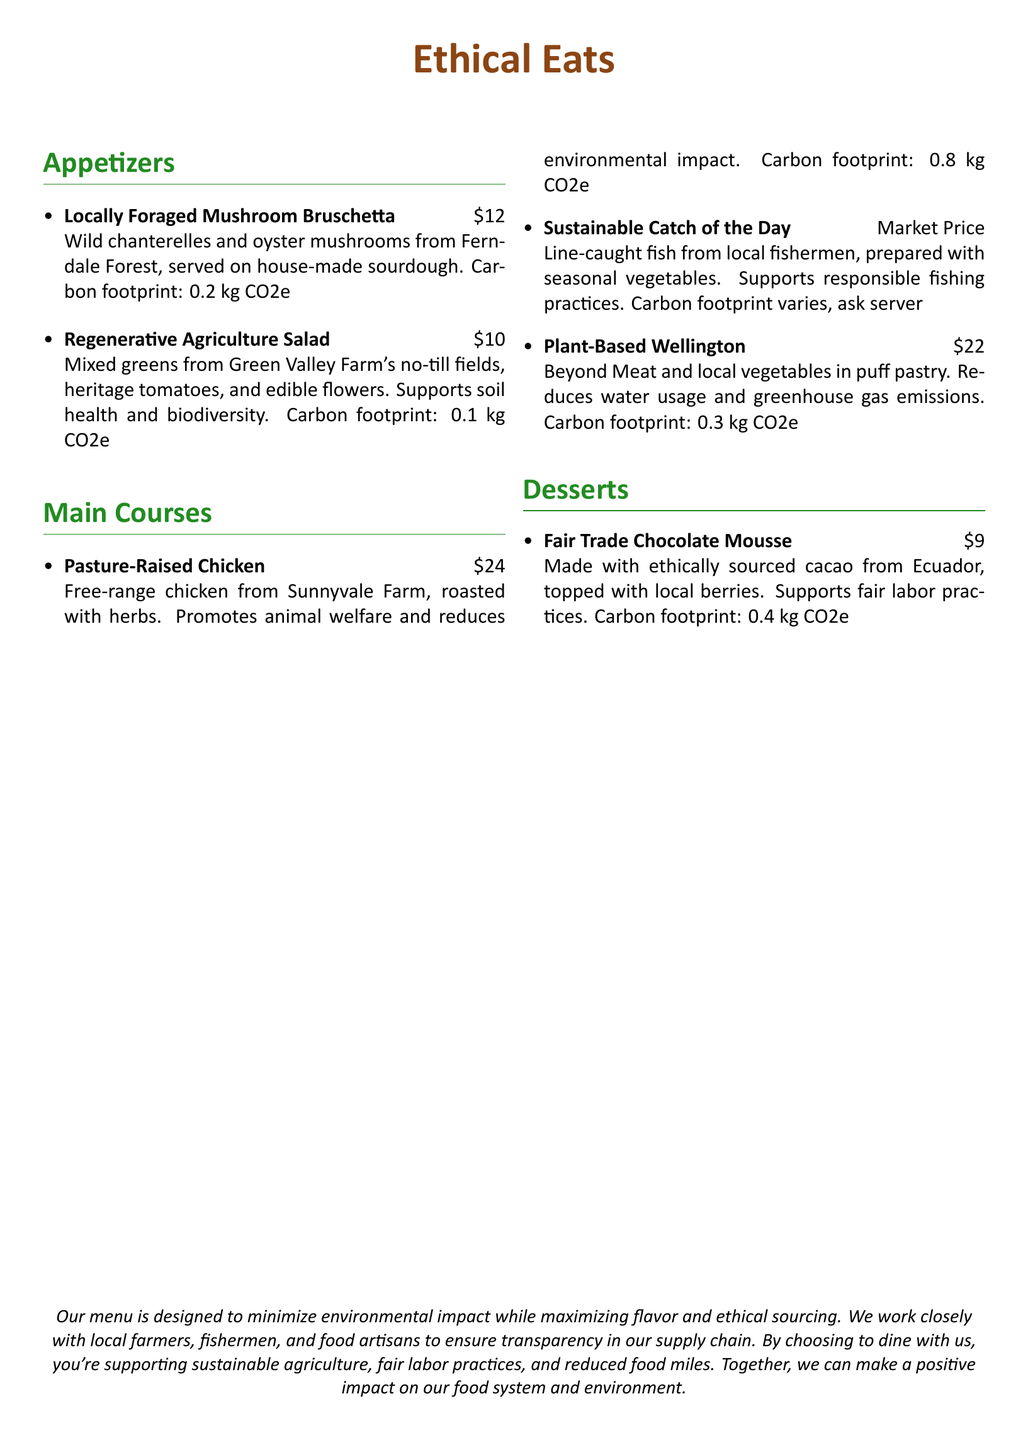What is the price of the Locally Foraged Mushroom Bruschetta? The price is listed next to the dish name in the menu.
Answer: $12 What ingredient is used in the Fair Trade Chocolate Mousse? The main ingredient is indicated in the description of the dessert.
Answer: Cacao What farming practice is mentioned in relation to the Regenerative Agriculture Salad? The description of the salad specifies the farming practice used for the greens.
Answer: No-till What is the carbon footprint of the Pasture-Raised Chicken? The carbon footprint is provided in the dish description for the chicken.
Answer: 0.8 kg CO2e Which dish supports responsible fishing practices? The dish description indicates the practice being supported.
Answer: Sustainable Catch of the Day How does the Plant-Based Wellington impact water usage? The description explains the environmental effect of choosing this dish.
Answer: Reduces water usage What is a key ethical sourcing practice mentioned in the introduction? The introduction highlights a particular practice related to sourcing ingredients.
Answer: Fair labor practices Which ingredient comes from local fishermen? The dish description specifies the source of this ingredient.
Answer: Fish What is the price range for the Sustainable Catch of the Day? The price information is explicitly stated in the menu section for main courses.
Answer: Market Price 